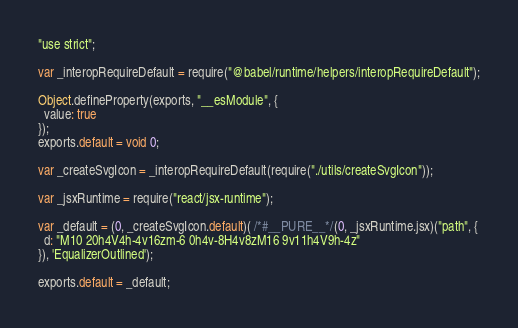Convert code to text. <code><loc_0><loc_0><loc_500><loc_500><_JavaScript_>"use strict";

var _interopRequireDefault = require("@babel/runtime/helpers/interopRequireDefault");

Object.defineProperty(exports, "__esModule", {
  value: true
});
exports.default = void 0;

var _createSvgIcon = _interopRequireDefault(require("./utils/createSvgIcon"));

var _jsxRuntime = require("react/jsx-runtime");

var _default = (0, _createSvgIcon.default)( /*#__PURE__*/(0, _jsxRuntime.jsx)("path", {
  d: "M10 20h4V4h-4v16zm-6 0h4v-8H4v8zM16 9v11h4V9h-4z"
}), 'EqualizerOutlined');

exports.default = _default;</code> 